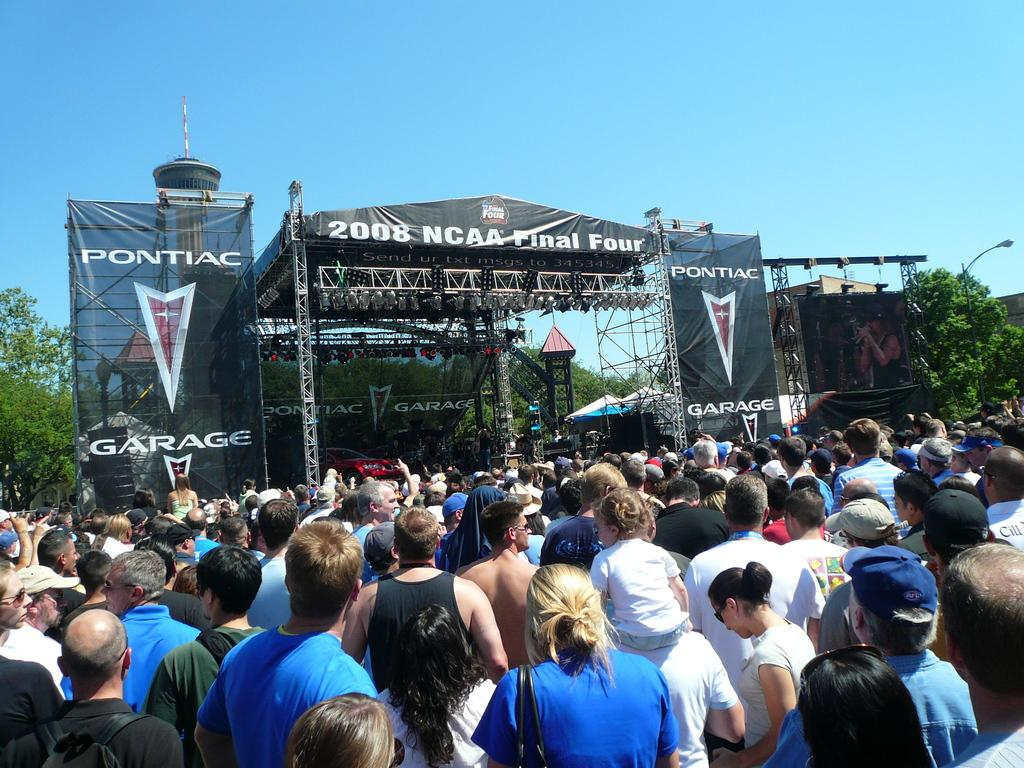How many people are in the image? There is a group of people in the image. What are the people wearing? The people are wearing different color dresses. What can be seen in the background of the image? There are trees, a light pole, banners, and a stage in the image. What type of lighting is present in the image? There are lights in the image. What is visible in the sky in the image? The sky is visible in the image. Are there any chickens involved in a fight in the image? There are no chickens or fights present in the image. What type of yard is visible in the image? There is no yard visible in the image; it features a group of people, trees, a light pole, banners, a stage, lights, and the sky. 